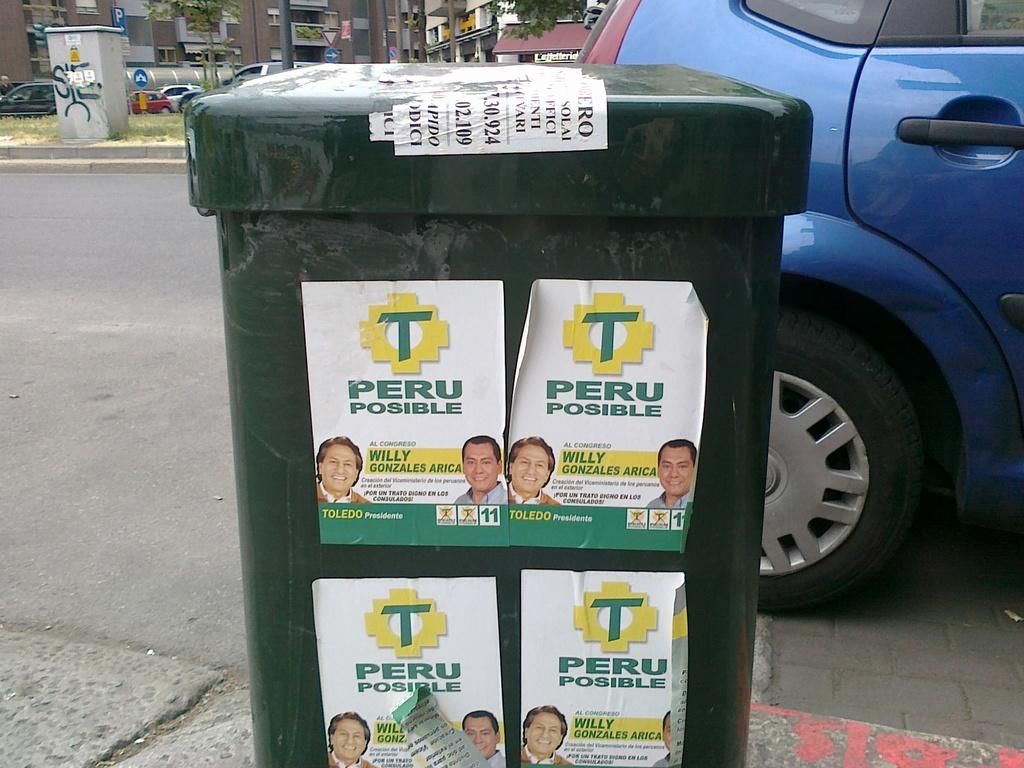<image>
Provide a brief description of the given image. Garbage can with a sign which says "PERU POSIBLE" on it. 